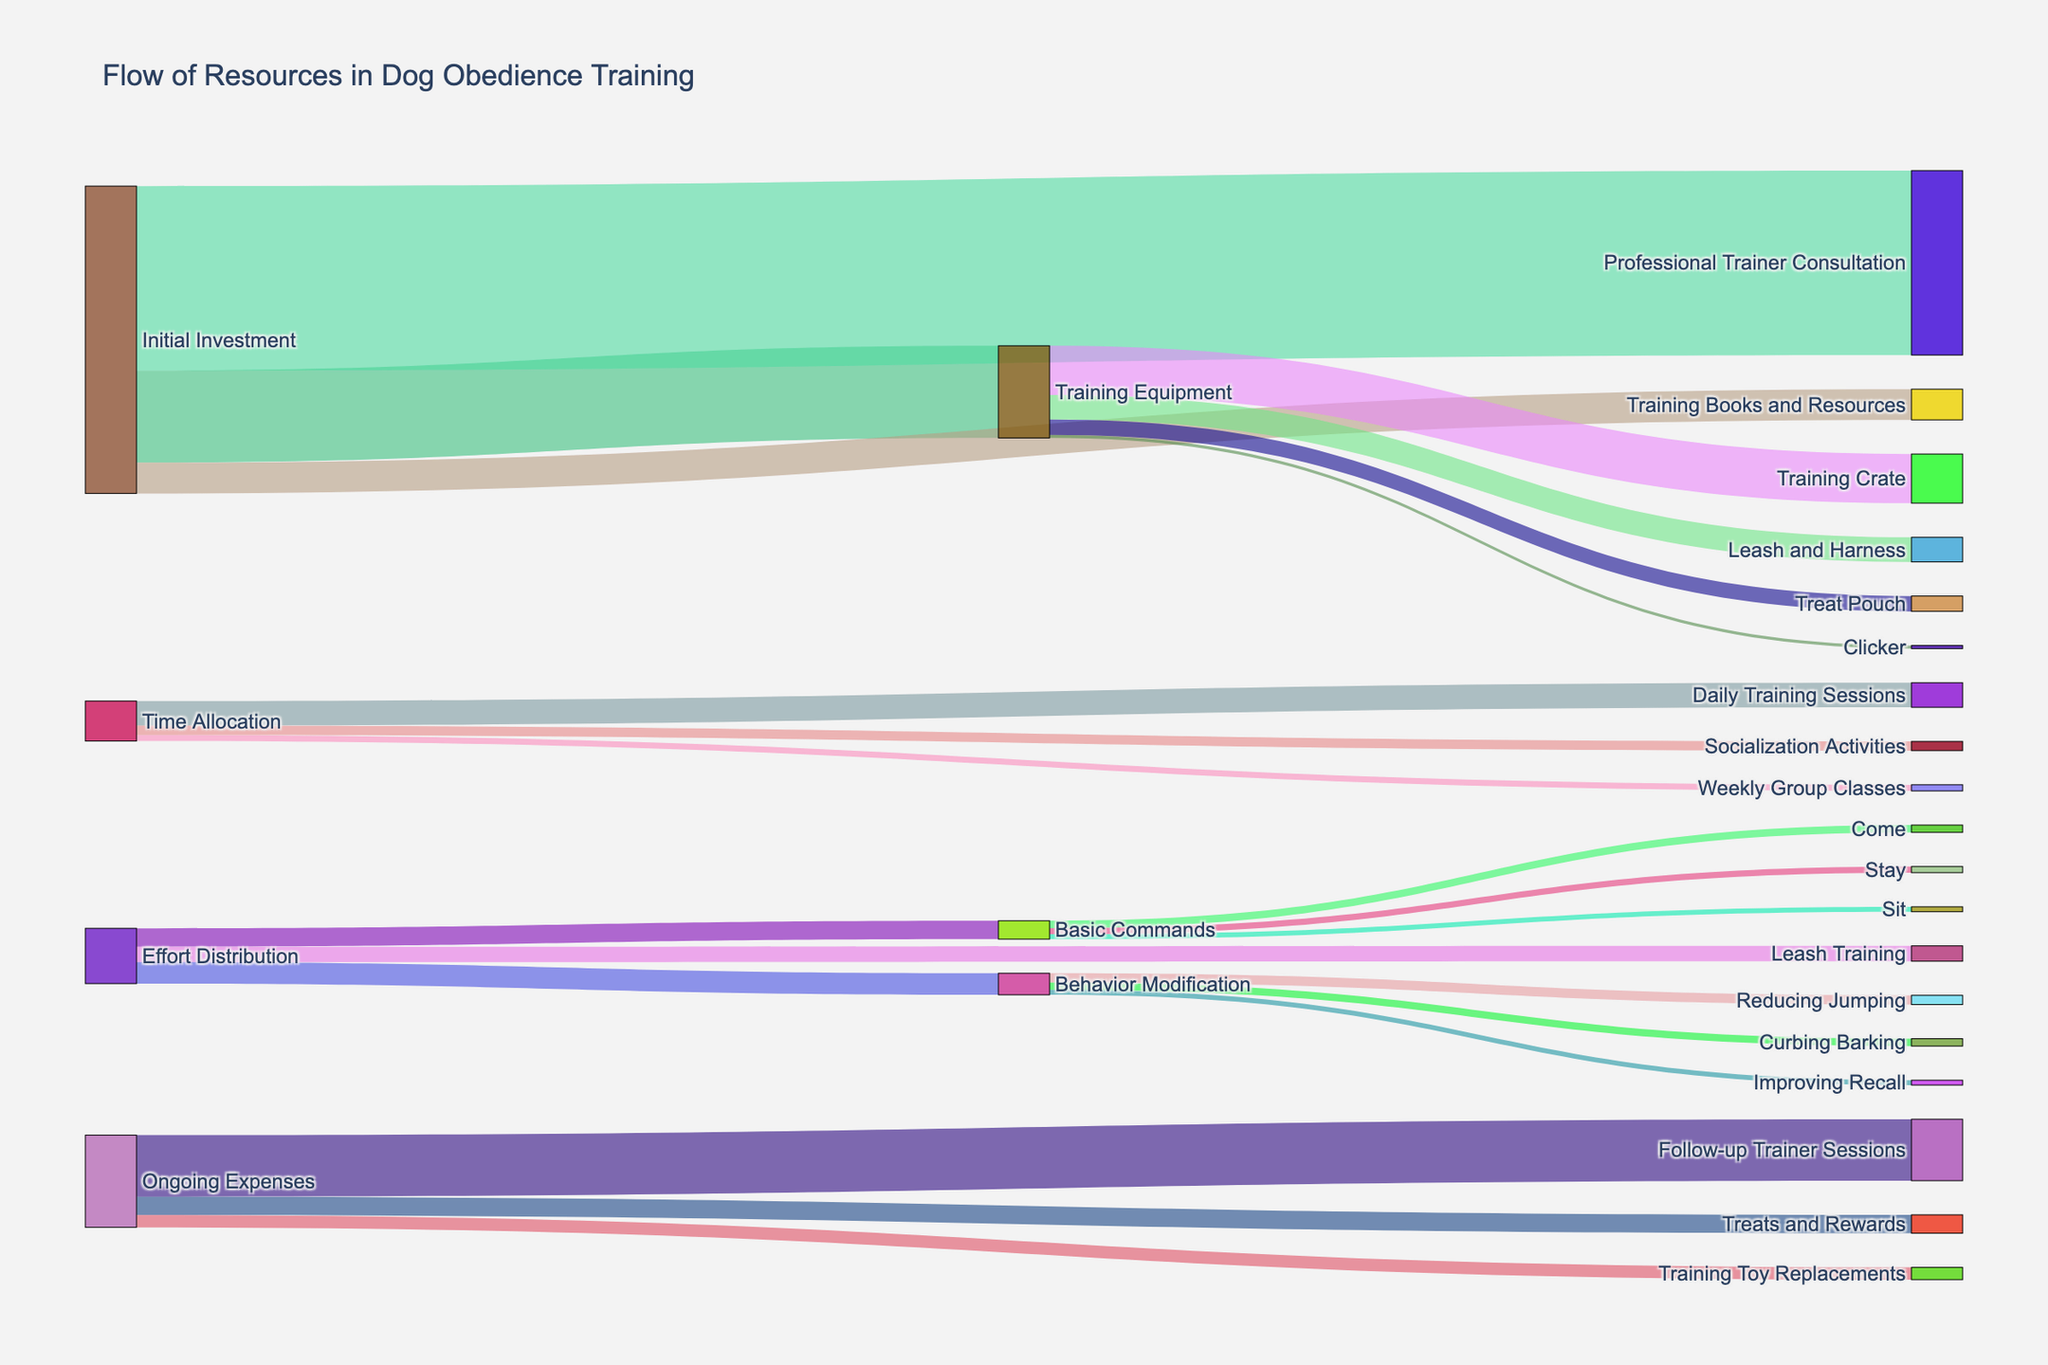Which category receives the highest initial investment? By looking at the nodes connected to 'Initial Investment' and comparing the values, we see that 'Professional Trainer Consultation' has the highest value of 300.
Answer: Professional Trainer Consultation How much total money is allocated to Training Equipment? Adding the values from 'Training Equipment' to its detailed components, we have (5 + 40 + 80 + 25) = 150.
Answer: 150 Which type of resource allocation has the highest total value: Initial Investment, Time Allocation, Effort Distribution, or Ongoing Expenses? Summing up the values in each category:
- Initial Investment: 150 + 300 + 50 = 500
- Time Allocation: 40 + 10 + 15 = 65
- Effort Distribution: 30 + 25 + 35 = 90
- Ongoing Expenses: 30 + 20 + 100 = 150
The 'Initial Investment' has the highest total value of 500.
Answer: Initial Investment Is more time allocated to Weekly Group Classes or Daily Training Sessions? Comparing the values connected to 'Time Allocation', Daily Training Sessions (40) > Weekly Group Classes (10).
Answer: Daily Training Sessions How does the effort distribution for Leash Training compare to Basic Commands? Comparing the values 'Leash Training' (25) to the sum of 'Sit' (8), 'Stay' (10), and 'Come' (12) under 'Basic Commands'. Total for Basic Commands = 8 + 10 + 12 = 30. So, Leash Training (25) < Basic Commands (30).
Answer: Basic Commands Which specific element under Behavior Modification receives the least effort? The values under 'Behavior Modification' indicate 'Improving Recall' receives 8, 'Curbing Barking' 12, and 'Reducing Jumping' 15. The least effort is assigned to 'Improving Recall' (8).
Answer: Improving Recall What is the difference in value between Follow-up Trainer Sessions and Training Toy Replacements? The values for 'Follow-up Trainer Sessions' is 100 and 'Training Toy Replacements' is 20. The difference is 100 - 20 = 80.
Answer: 80 Are more resources spent on Treats and Rewards or on Training Toy Replacements? Comparing values under 'Ongoing Expenses', Treats and Rewards (30) > Training Toy Replacements (20).
Answer: Treats and Rewards How much total effort is allocated to effort distribution activities like Basic Commands, Leash Training, and Behavior Modification? Summing up the values connected to 'Effort Distribution', Basic Commands (30) + Leash Training (25) + Behavior Modification (35) = 90.
Answer: 90 